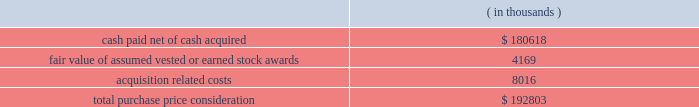Synopsys , inc .
Notes to consolidated financial statements 2014 ( continued ) and other electronic applications markets .
The company believes the acquisition will expand its technology portfolio , channel reach and total addressable market by adding complementary products and expertise for fpga solutions and rapid asic prototyping .
Purchase price .
Synopsys paid $ 8.00 per share for all outstanding shares including certain vested options of synplicity for an aggregate cash payment of $ 223.3 million .
Additionally , synopsys assumed certain employee stock options and restricted stock units , collectively called 201cstock awards . 201d the total purchase consideration consisted of: .
Acquisition related costs consist primarily of professional services , severance and employee related costs and facilities closure costs of which $ 6.8 million have been paid as of october 31 , 2009 .
Fair value of stock awards assumed .
An aggregate of 4.7 million shares of synplicity stock options and restricted stock units were exchanged for synopsys stock options and restricted stock units at an exchange ratio of 0.3392 per share .
The fair value of stock options assumed was determined using a black-scholes valuation model .
The fair value of stock awards vested or earned of $ 4.2 million was included as part of the purchase price .
The fair value of unvested awards of $ 5.0 million will be recorded as operating expense over the remaining service periods on a straight-line basis .
Purchase price allocation .
The company allocated $ 80.0 million of the purchase price to identifiable intangible assets to be amortized over two to seven years .
In-process research and development expense related to these acquisitions was $ 4.8 million .
Goodwill , representing the excess of the purchase price over the fair value of tangible and identifiable intangible assets acquired , was $ 120.3 million and will not be amortized .
Goodwill primarily resulted from the company 2019s expectation of cost synergies and sales growth from the integration of synplicity 2019s technology with the company 2019s technology and operations to provide an expansion of products and market reach .
Fiscal 2007 acquisitions during fiscal year 2007 , the company completed certain purchase acquisitions for cash .
The company allocated the total purchase considerations of $ 54.8 million ( which included acquisition related costs of $ 1.4 million ) to the assets and liabilities acquired , including identifiable intangible assets , based on their respective fair values at the acquisition dates , resulting in aggregate goodwill of $ 36.6 million .
Acquired identifiable intangible assets of $ 14.3 million are being amortized over two to nine years .
In-process research and development expense related to these acquisitions was $ 3.2 million. .
What percentage of the total purchase price consideration was identifiable intangible assets? 
Computations: ((80.0 * 1000) / 192803)
Answer: 0.41493. 